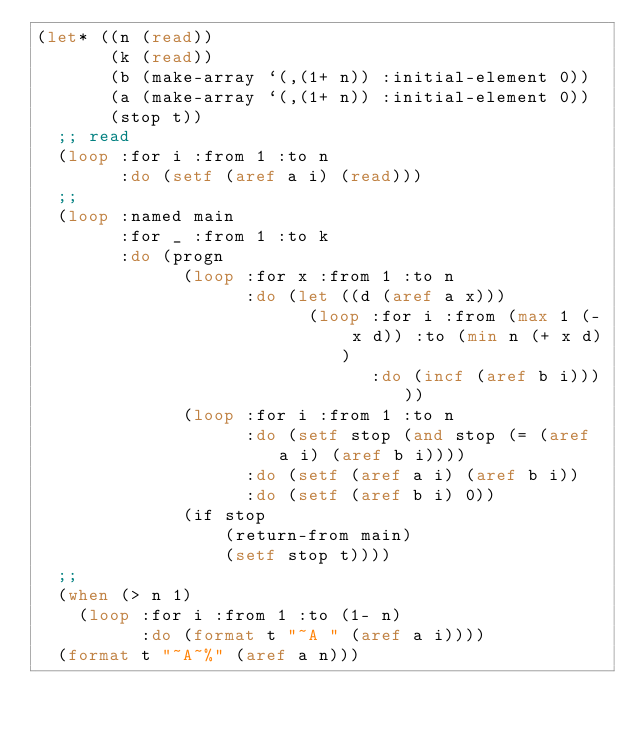Convert code to text. <code><loc_0><loc_0><loc_500><loc_500><_Lisp_>(let* ((n (read))
       (k (read))
       (b (make-array `(,(1+ n)) :initial-element 0))
       (a (make-array `(,(1+ n)) :initial-element 0))
       (stop t))
  ;; read 
  (loop :for i :from 1 :to n
        :do (setf (aref a i) (read)))
  ;;
  (loop :named main
        :for _ :from 1 :to k
        :do (progn 
              (loop :for x :from 1 :to n
                    :do (let ((d (aref a x)))
                          (loop :for i :from (max 1 (- x d)) :to (min n (+ x d))
                                :do (incf (aref b i)))))
              (loop :for i :from 1 :to n
                    :do (setf stop (and stop (= (aref a i) (aref b i))))
                    :do (setf (aref a i) (aref b i))
                    :do (setf (aref b i) 0))
              (if stop 
                  (return-from main)
                  (setf stop t))))
  ;;
  (when (> n 1)
    (loop :for i :from 1 :to (1- n)
          :do (format t "~A " (aref a i))))
  (format t "~A~%" (aref a n)))
</code> 